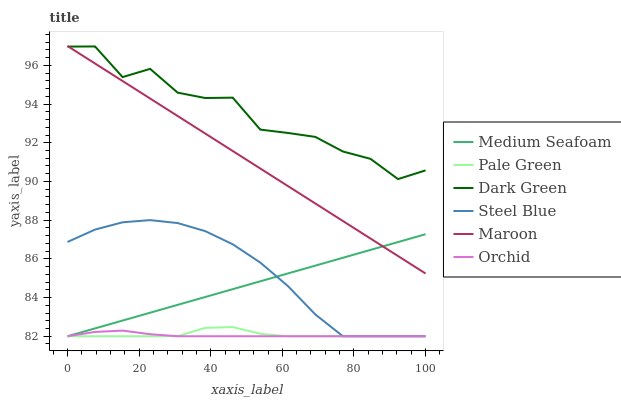Does Orchid have the minimum area under the curve?
Answer yes or no. Yes. Does Dark Green have the maximum area under the curve?
Answer yes or no. Yes. Does Maroon have the minimum area under the curve?
Answer yes or no. No. Does Maroon have the maximum area under the curve?
Answer yes or no. No. Is Maroon the smoothest?
Answer yes or no. Yes. Is Dark Green the roughest?
Answer yes or no. Yes. Is Pale Green the smoothest?
Answer yes or no. No. Is Pale Green the roughest?
Answer yes or no. No. Does Steel Blue have the lowest value?
Answer yes or no. Yes. Does Maroon have the lowest value?
Answer yes or no. No. Does Maroon have the highest value?
Answer yes or no. Yes. Does Pale Green have the highest value?
Answer yes or no. No. Is Orchid less than Dark Green?
Answer yes or no. Yes. Is Dark Green greater than Orchid?
Answer yes or no. Yes. Does Pale Green intersect Medium Seafoam?
Answer yes or no. Yes. Is Pale Green less than Medium Seafoam?
Answer yes or no. No. Is Pale Green greater than Medium Seafoam?
Answer yes or no. No. Does Orchid intersect Dark Green?
Answer yes or no. No. 